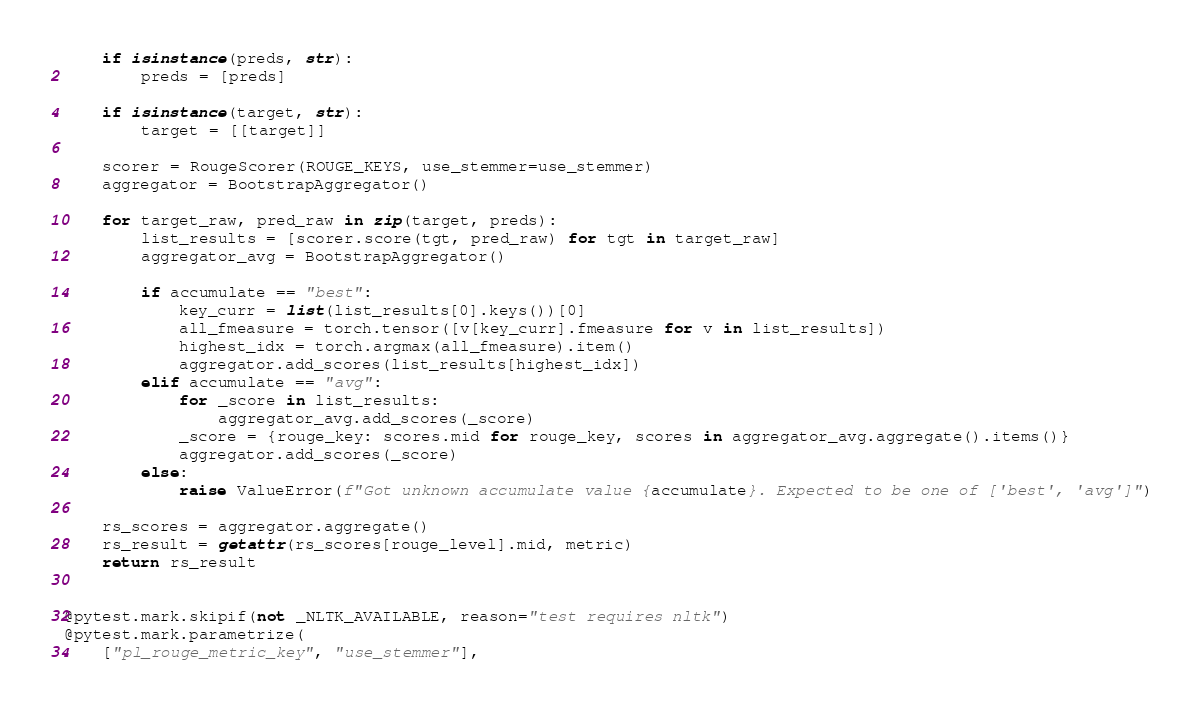Convert code to text. <code><loc_0><loc_0><loc_500><loc_500><_Python_>    if isinstance(preds, str):
        preds = [preds]

    if isinstance(target, str):
        target = [[target]]

    scorer = RougeScorer(ROUGE_KEYS, use_stemmer=use_stemmer)
    aggregator = BootstrapAggregator()

    for target_raw, pred_raw in zip(target, preds):
        list_results = [scorer.score(tgt, pred_raw) for tgt in target_raw]
        aggregator_avg = BootstrapAggregator()

        if accumulate == "best":
            key_curr = list(list_results[0].keys())[0]
            all_fmeasure = torch.tensor([v[key_curr].fmeasure for v in list_results])
            highest_idx = torch.argmax(all_fmeasure).item()
            aggregator.add_scores(list_results[highest_idx])
        elif accumulate == "avg":
            for _score in list_results:
                aggregator_avg.add_scores(_score)
            _score = {rouge_key: scores.mid for rouge_key, scores in aggregator_avg.aggregate().items()}
            aggregator.add_scores(_score)
        else:
            raise ValueError(f"Got unknown accumulate value {accumulate}. Expected to be one of ['best', 'avg']")

    rs_scores = aggregator.aggregate()
    rs_result = getattr(rs_scores[rouge_level].mid, metric)
    return rs_result


@pytest.mark.skipif(not _NLTK_AVAILABLE, reason="test requires nltk")
@pytest.mark.parametrize(
    ["pl_rouge_metric_key", "use_stemmer"],</code> 